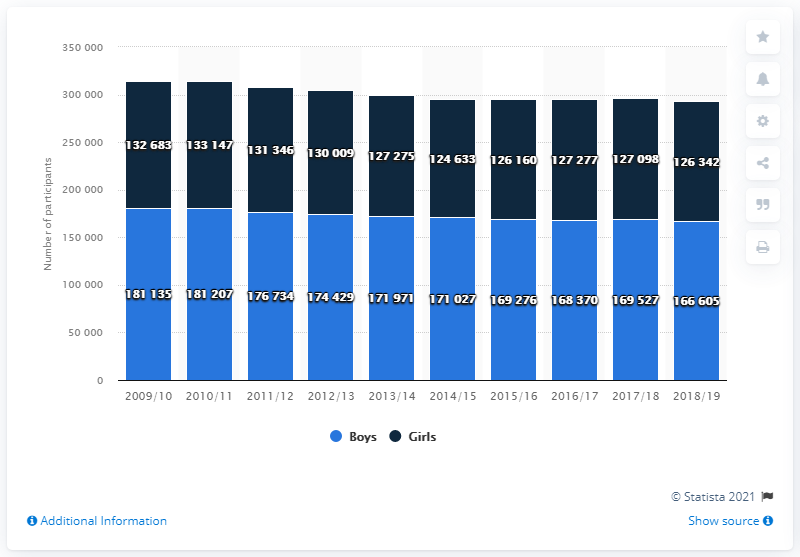Can you tell me the total number of participants for boys and girls in 2015/16? The total number of participants for boys and girls in 2015/16 is 337,966, with 168,370 boys and 169,596 girls. 